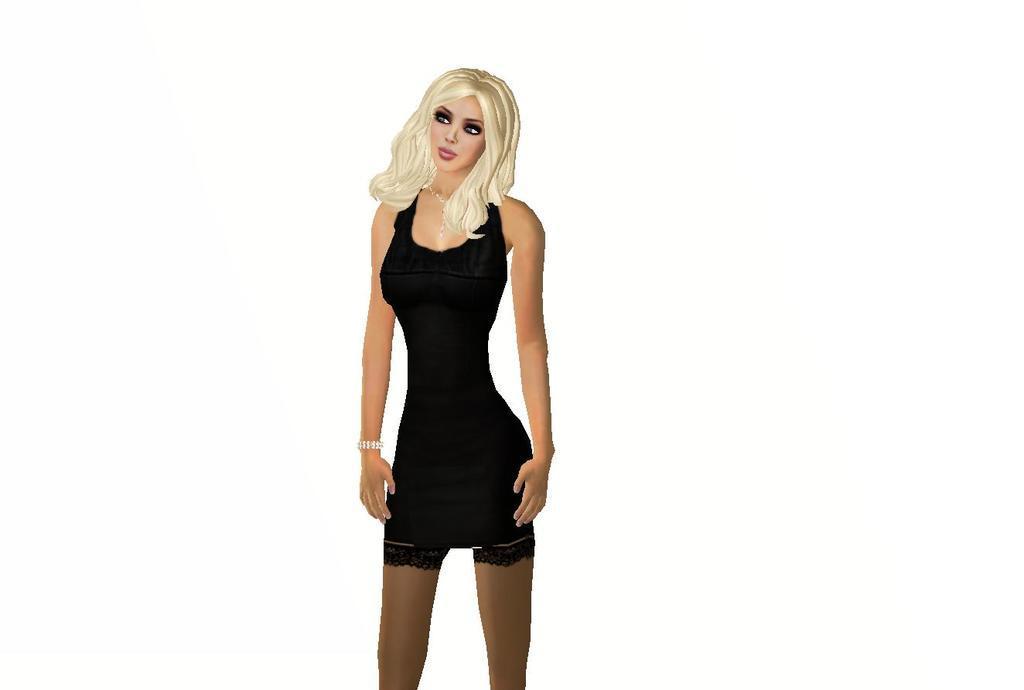How would you summarize this image in a sentence or two? In this picture we can see an animated image of a girl and in the background we can see it is white color. 